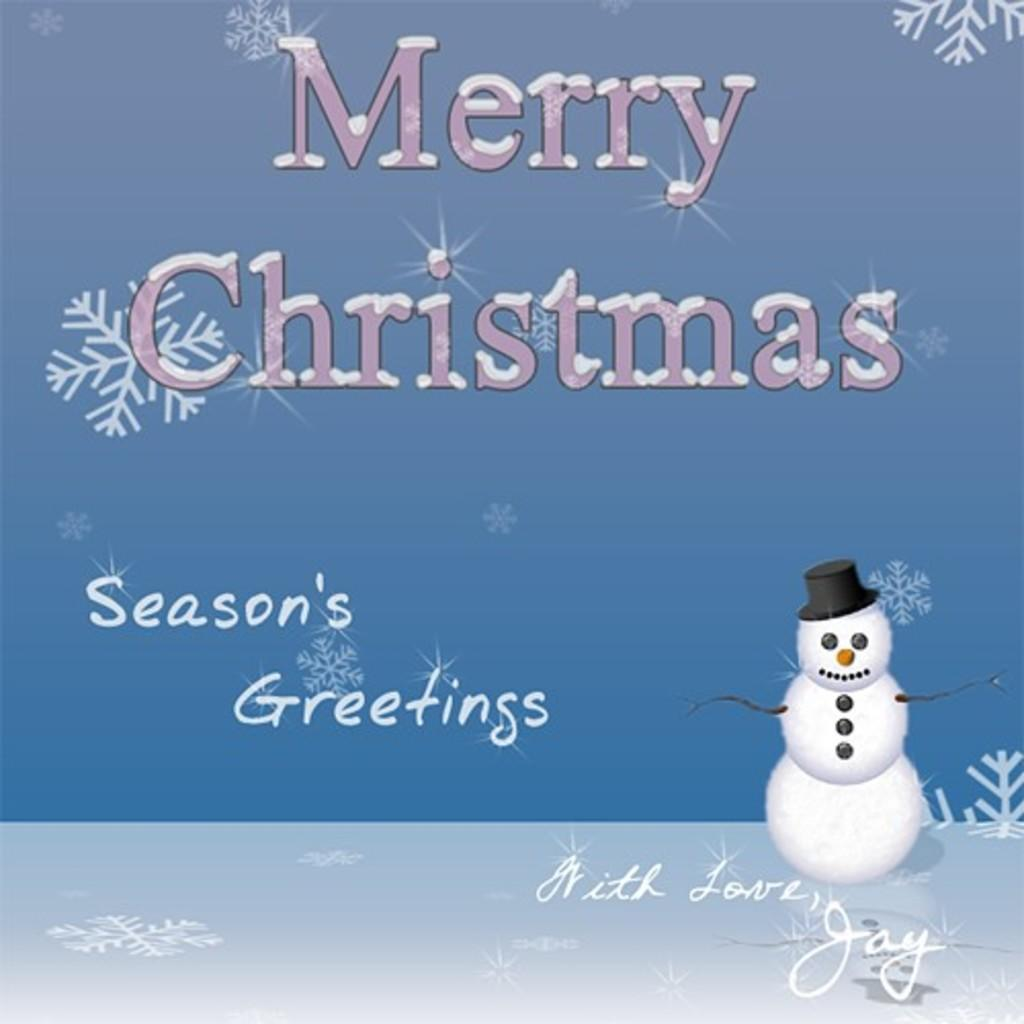What is the main subject in the image? There is a snowman in the image. What is the snowman resting on or standing on? The snowman is on a surface. What else can be seen in the image besides the snowman? There is text and symbols in the image. How many times does the curve appear in the image? There is no curve present in the image. What type of mailbox is visible in the image? There is no mailbox present in the image. 